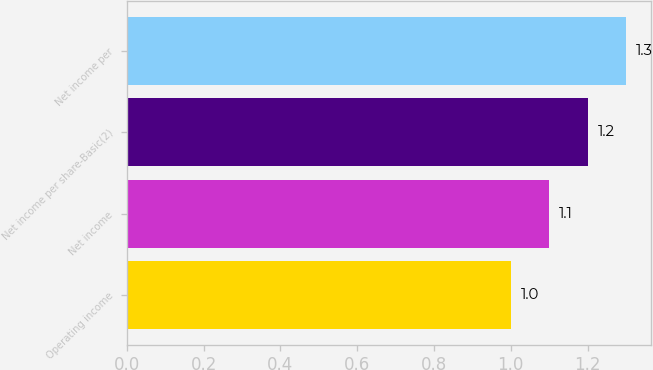Convert chart. <chart><loc_0><loc_0><loc_500><loc_500><bar_chart><fcel>Operating income<fcel>Net income<fcel>Net income per share-Basic(2)<fcel>Net income per<nl><fcel>1<fcel>1.1<fcel>1.2<fcel>1.3<nl></chart> 